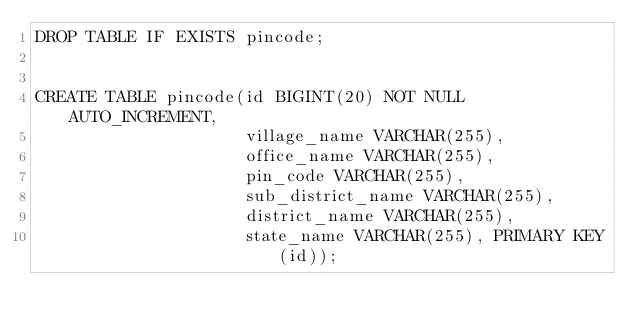<code> <loc_0><loc_0><loc_500><loc_500><_SQL_>DROP TABLE IF EXISTS pincode;


CREATE TABLE pincode(id BIGINT(20) NOT NULL AUTO_INCREMENT, 
                     village_name VARCHAR(255), 
                     office_name VARCHAR(255), 
                     pin_code VARCHAR(255), 
                     sub_district_name VARCHAR(255), 
                     district_name VARCHAR(255), 
                     state_name VARCHAR(255), PRIMARY KEY(id));</code> 